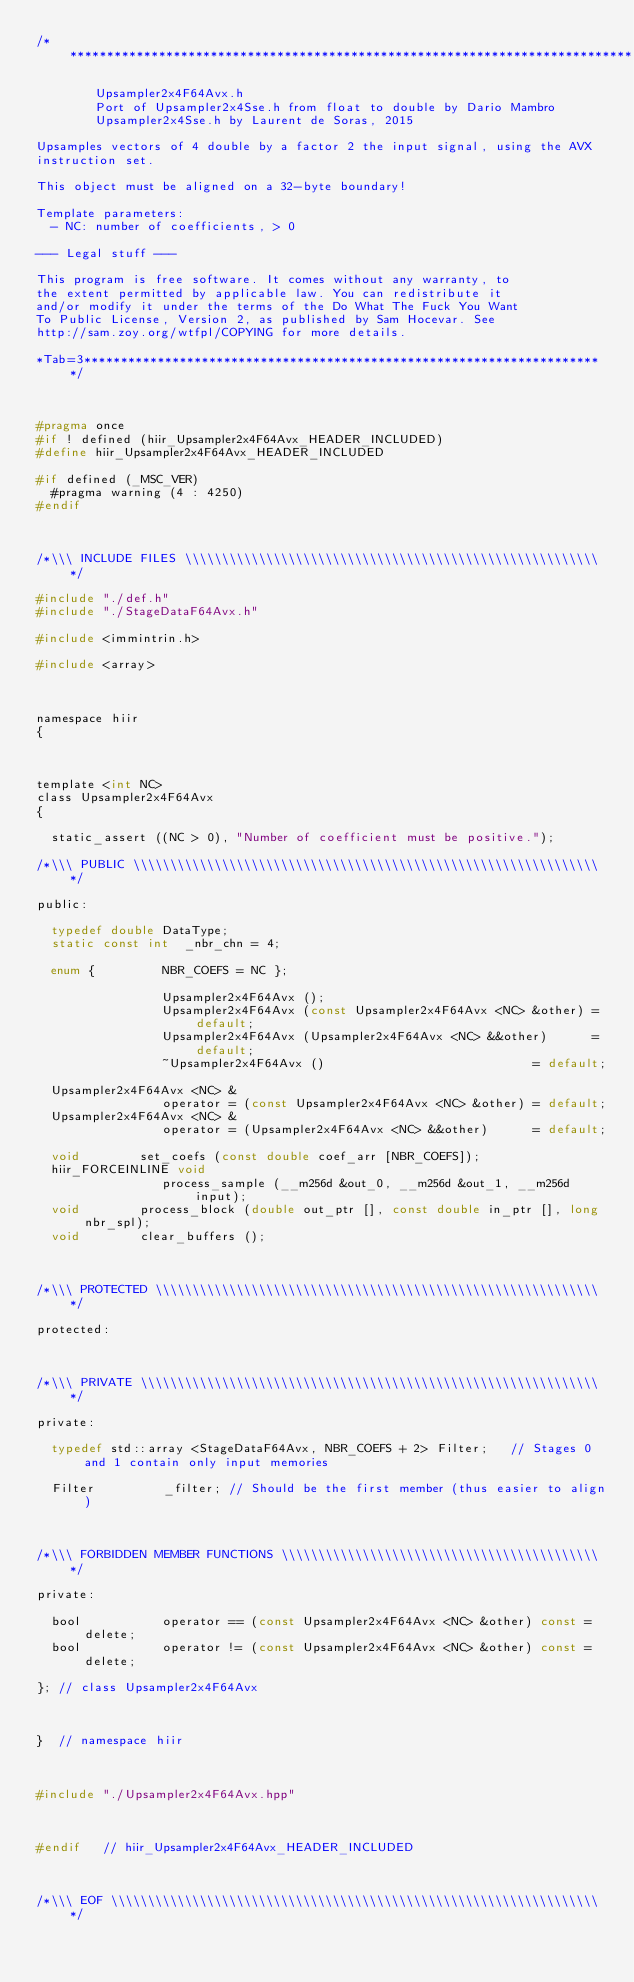Convert code to text. <code><loc_0><loc_0><loc_500><loc_500><_C_>/*****************************************************************************

        Upsampler2x4F64Avx.h
        Port of Upsampler2x4Sse.h from float to double by Dario Mambro
        Upsampler2x4Sse.h by Laurent de Soras, 2015

Upsamples vectors of 4 double by a factor 2 the input signal, using the AVX
instruction set.

This object must be aligned on a 32-byte boundary!

Template parameters:
	- NC: number of coefficients, > 0

--- Legal stuff ---

This program is free software. It comes without any warranty, to
the extent permitted by applicable law. You can redistribute it
and/or modify it under the terms of the Do What The Fuck You Want
To Public License, Version 2, as published by Sam Hocevar. See
http://sam.zoy.org/wtfpl/COPYING for more details.

*Tab=3***********************************************************************/



#pragma once
#if ! defined (hiir_Upsampler2x4F64Avx_HEADER_INCLUDED)
#define hiir_Upsampler2x4F64Avx_HEADER_INCLUDED

#if defined (_MSC_VER)
	#pragma warning (4 : 4250)
#endif



/*\\\ INCLUDE FILES \\\\\\\\\\\\\\\\\\\\\\\\\\\\\\\\\\\\\\\\\\\\\\\\\\\\\\\\*/

#include "./def.h"
#include "./StageDataF64Avx.h"

#include <immintrin.h> 

#include <array>



namespace hiir
{



template <int NC>
class Upsampler2x4F64Avx
{

	static_assert ((NC > 0), "Number of coefficient must be positive.");

/*\\\ PUBLIC \\\\\\\\\\\\\\\\\\\\\\\\\\\\\\\\\\\\\\\\\\\\\\\\\\\\\\\\\\\\\\\*/

public:

	typedef double DataType;
	static const int  _nbr_chn = 4;

	enum {         NBR_COEFS = NC };

	               Upsampler2x4F64Avx ();
	               Upsampler2x4F64Avx (const Upsampler2x4F64Avx <NC> &other) = default;
	               Upsampler2x4F64Avx (Upsampler2x4F64Avx <NC> &&other)      = default;
	               ~Upsampler2x4F64Avx ()                            = default;

	Upsampler2x4F64Avx <NC> &
	               operator = (const Upsampler2x4F64Avx <NC> &other) = default;
	Upsampler2x4F64Avx <NC> &
	               operator = (Upsampler2x4F64Avx <NC> &&other)      = default;

	void				set_coefs (const double coef_arr [NBR_COEFS]);
	hiir_FORCEINLINE void
	               process_sample (__m256d &out_0, __m256d &out_1, __m256d input);
	void				process_block (double out_ptr [], const double in_ptr [], long nbr_spl);
	void				clear_buffers ();



/*\\\ PROTECTED \\\\\\\\\\\\\\\\\\\\\\\\\\\\\\\\\\\\\\\\\\\\\\\\\\\\\\\\\\\\*/

protected:



/*\\\ PRIVATE \\\\\\\\\\\\\\\\\\\\\\\\\\\\\\\\\\\\\\\\\\\\\\\\\\\\\\\\\\\\\\*/

private:

	typedef std::array <StageDataF64Avx, NBR_COEFS + 2> Filter;   // Stages 0 and 1 contain only input memories

	Filter         _filter; // Should be the first member (thus easier to align)



/*\\\ FORBIDDEN MEMBER FUNCTIONS \\\\\\\\\\\\\\\\\\\\\\\\\\\\\\\\\\\\\\\\\\\*/

private:

	bool           operator == (const Upsampler2x4F64Avx <NC> &other) const = delete;
	bool           operator != (const Upsampler2x4F64Avx <NC> &other) const = delete;

}; // class Upsampler2x4F64Avx



}  // namespace hiir



#include "./Upsampler2x4F64Avx.hpp"



#endif   // hiir_Upsampler2x4F64Avx_HEADER_INCLUDED



/*\\\ EOF \\\\\\\\\\\\\\\\\\\\\\\\\\\\\\\\\\\\\\\\\\\\\\\\\\\\\\\\\\\\\\\\\\*/
</code> 